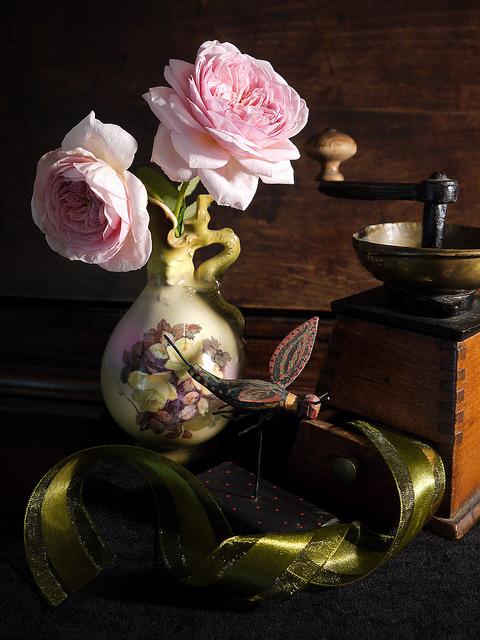Is the vase plain?
Be succinct. No. How many flowers are on the counter?
Concise answer only. 2. What kind of flowers?
Short answer required. Roses. 